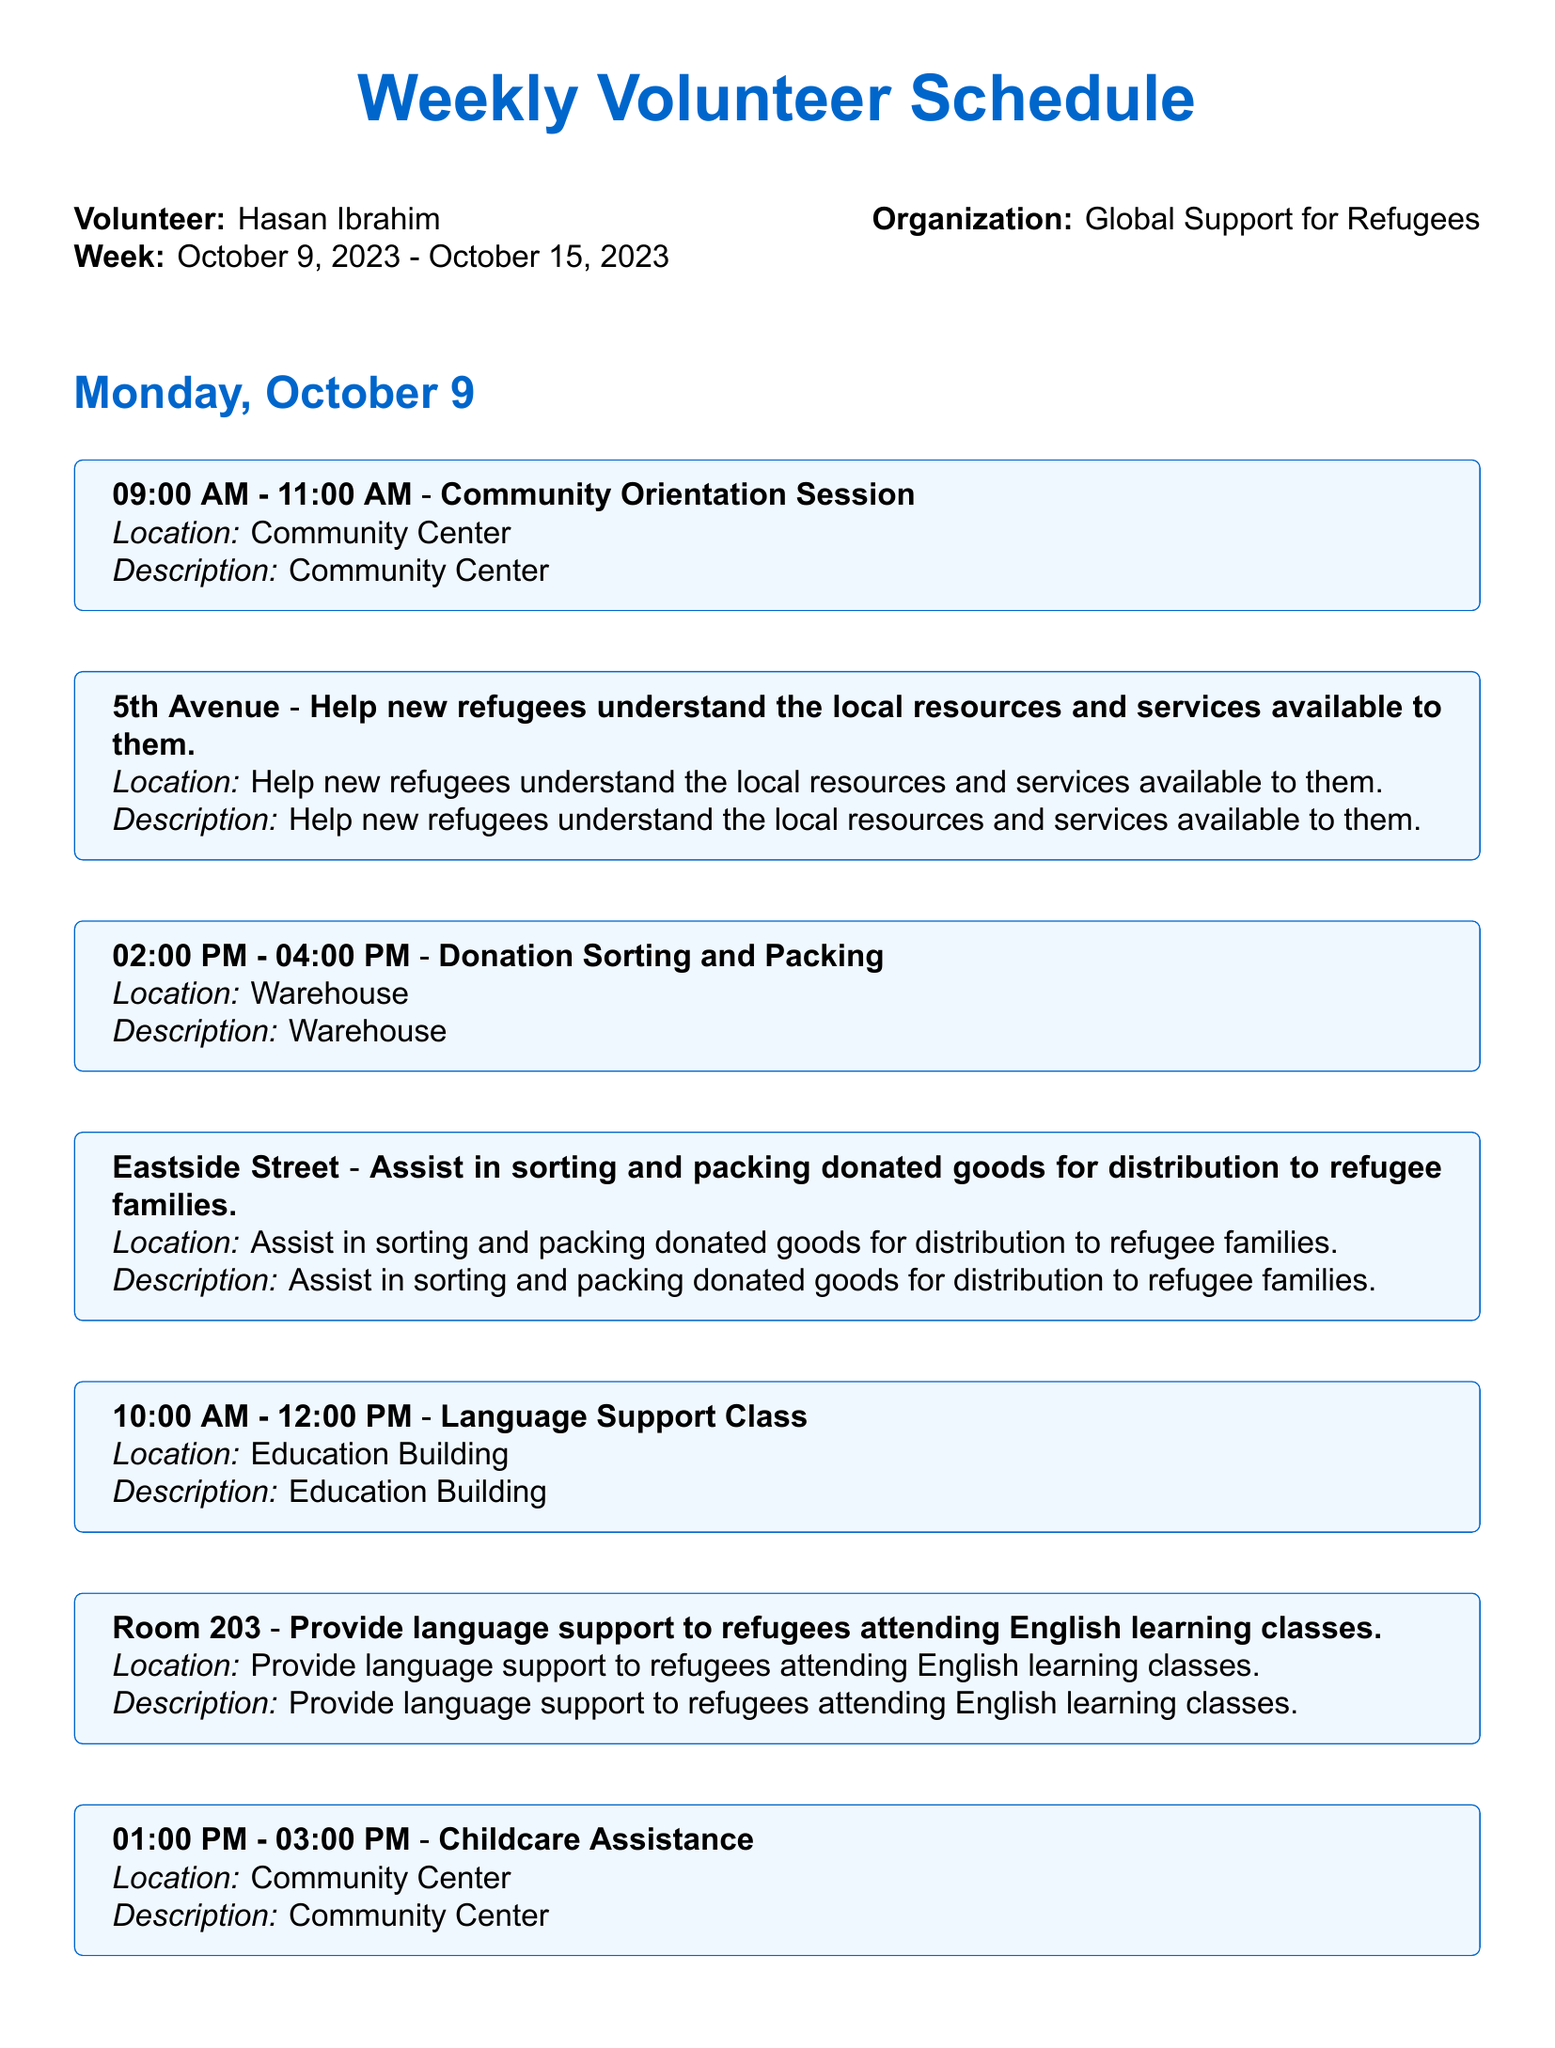what is the name of the volunteer? The volunteer's name is mentioned at the beginning of the document as Hasan Ibrahim.
Answer: Hasan Ibrahim which organization does the volunteer support? The organization is stated in the document as Global Support for Refugees.
Answer: Global Support for Refugees what days are scheduled for volunteering? The days listed in the document are Monday, Wednesday, Friday, and Saturday.
Answer: Monday, Wednesday, Friday, Saturday how many tasks are assigned on October 11, 2023? Counting the tasks listed for that date shows there are four tasks scheduled.
Answer: 4 what time does the Community Orientation Session start? The start time for the Community Orientation Session is specified as 09:00 AM.
Answer: 09:00 AM where is the Food Distribution location? The document explicitly states that the Food Distribution is at the Food Bank, Downtown.
Answer: Food Bank, Downtown what is the duration of the Cultural Exchange Program task? The duration is found in the description of that task as 12:00 PM - 02:00 PM, which is two hours.
Answer: 2 hours which task requires providing childcare assistance? The document mentions Childcare Assistance, making it clear that this is the task relevant for this query.
Answer: Childcare Assistance what is the date range for this volunteer schedule? The date range is clearly articulated at the beginning of the document as October 9, 2023 - October 15, 2023.
Answer: October 9, 2023 - October 15, 2023 